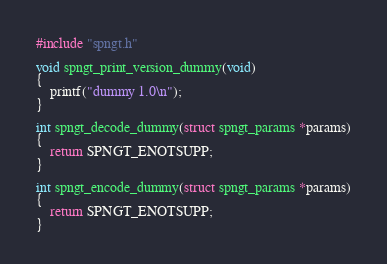Convert code to text. <code><loc_0><loc_0><loc_500><loc_500><_C_>#include "spngt.h"

void spngt_print_version_dummy(void)
{
    printf("dummy 1.0\n");
}

int spngt_decode_dummy(struct spngt_params *params)
{
    return SPNGT_ENOTSUPP;
}

int spngt_encode_dummy(struct spngt_params *params)
{
    return SPNGT_ENOTSUPP;
}
</code> 